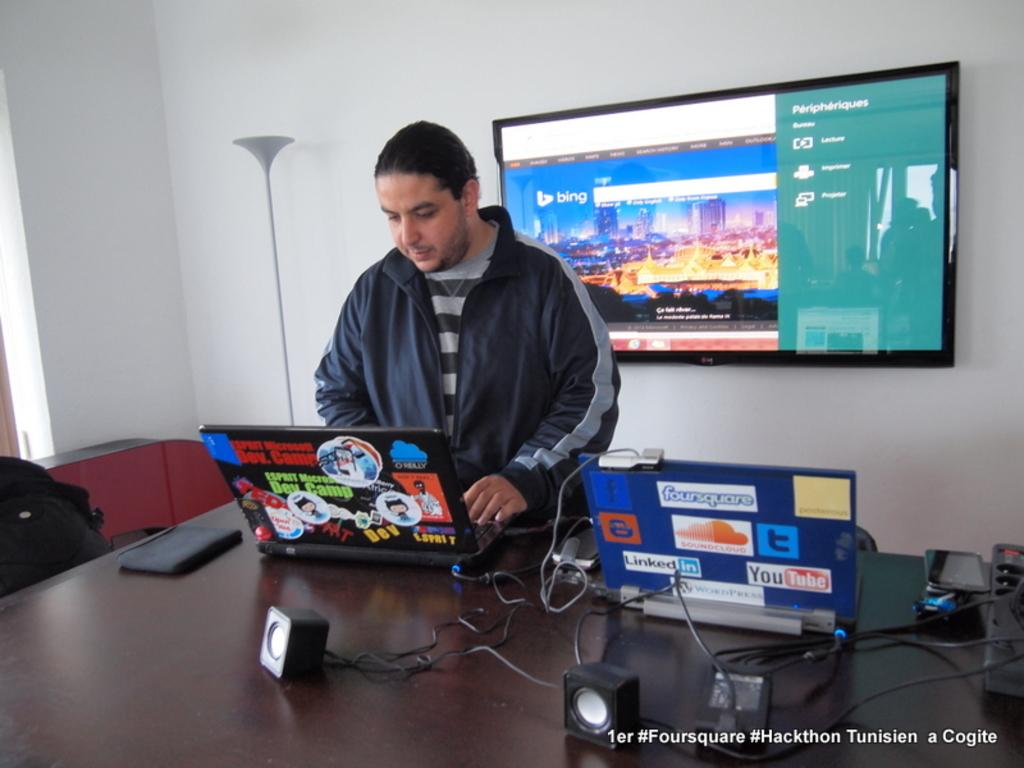Provide a one-sentence caption for the provided image. A man works on a computer with Dev. Camp stickers all over it next to another computer. 